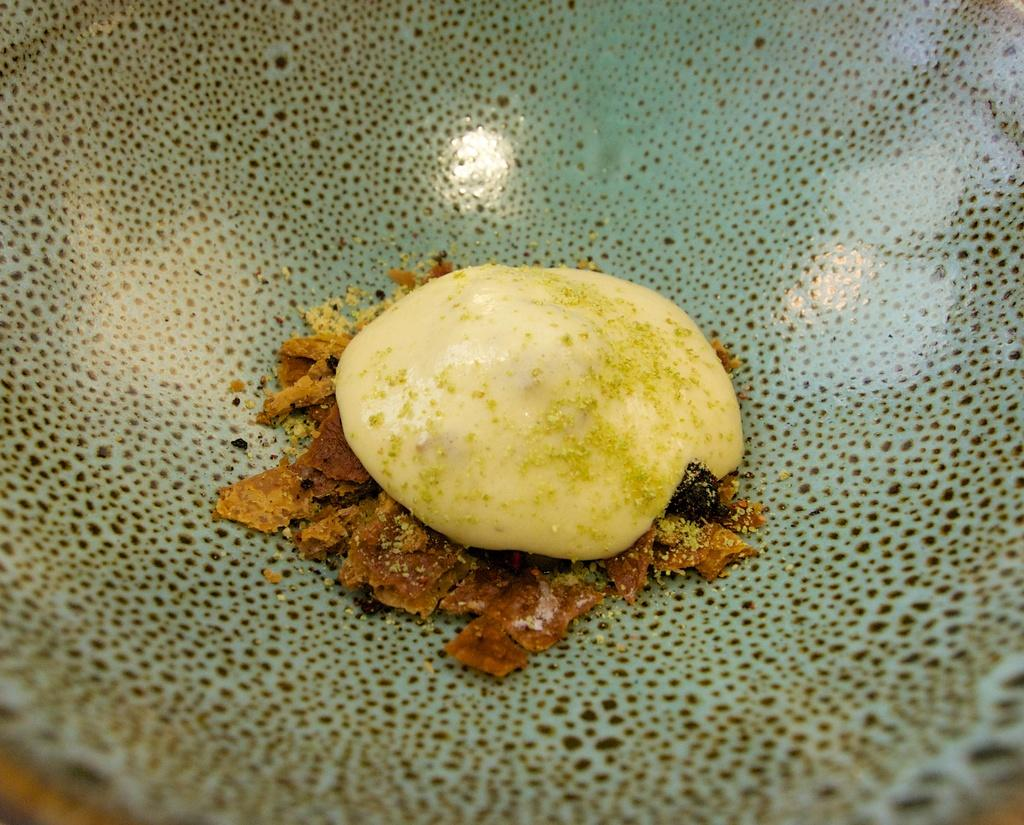What is present in the image? There is food in the image. Can you describe the location of the food? The food is on a platform. What type of whip can be seen in the image? There is no whip present in the image. Is there a jar containing any ingredients for the food in the image? The facts provided do not mention a jar containing any ingredients for the food. Can you spot a toad near the food in the image? There is no toad present in the image. 